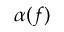<formula> <loc_0><loc_0><loc_500><loc_500>\alpha ( f )</formula> 